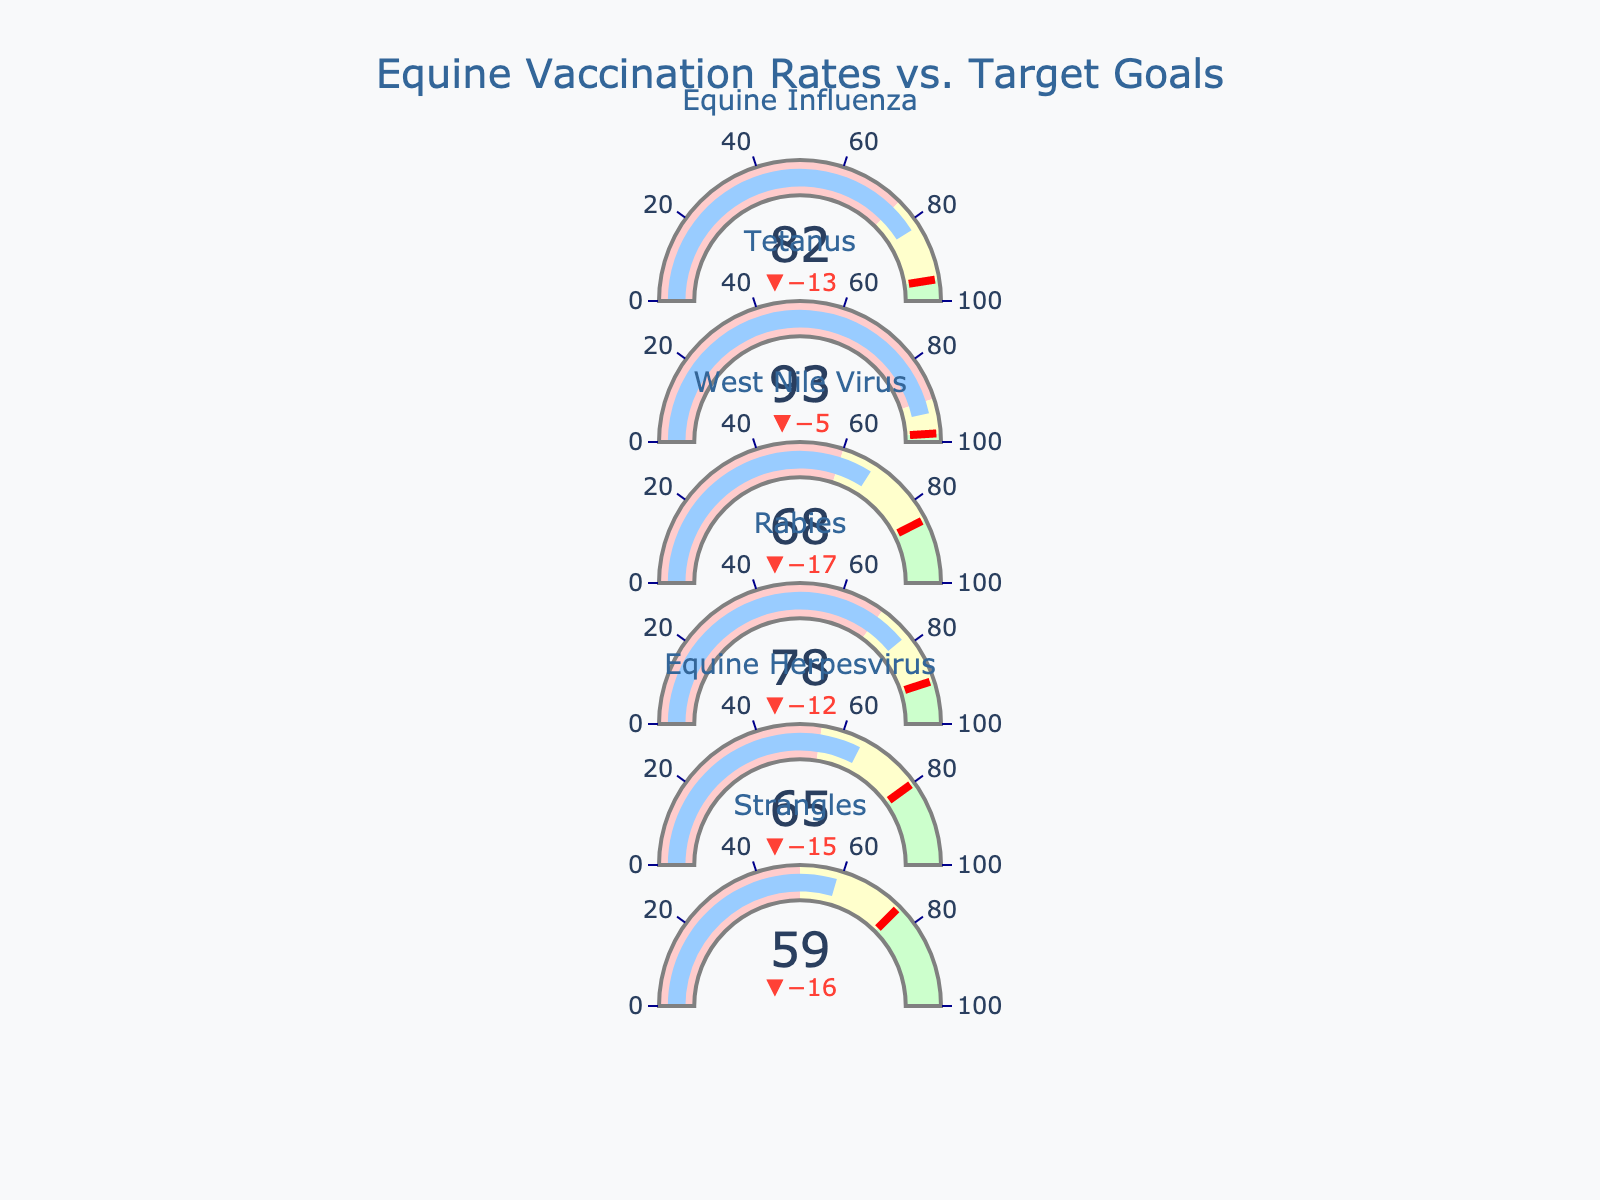What is the actual vaccination rate for Tetanus? Look at the section labeled "Tetanus" in the chart to find the actual vaccination rate.
Answer: 93 What is the discrepancy between the actual and target vaccination rates for West Nile Virus? Find the actual vaccination rate for West Nile Virus (68) and the target rate (85). Subtract the actual rate from the target rate: 85 - 68 = 17
Answer: 17 Among the diseases listed, which one has the lowest vaccination rate? Compare the actual vaccination rates for all diseases: Equine Influenza (82), Tetanus (93), West Nile Virus (68), Rabies (78), Equine Herpesvirus (65), Strangles (59). The lowest rate is for Strangles.
Answer: Strangles How many diseases have an actual vaccination rate above their respective comparison thresholds? Compare actual rates against comparison thresholds: Equine Influenza (82 > 75), Tetanus (93 > 90), West Nile Virus (68 > 60), Rabies (78 > 70), Equine Herpesvirus (65 > 55), Strangles (59 > 50). All six diseases meet this condition.
Answer: 6 Which disease has the smallest difference between the actual and target vaccination rates? Calculate differences: Equine Influenza (95-82=13), Tetanus (98-93=5), West Nile Virus (85-68=17), Rabies (90-78=12), Equine Herpesvirus (80-65=15), Strangles (75-59=16). The smallest difference is for Tetanus.
Answer: Tetanus What's the average actual vaccination rate across all diseases? Add all actual rates: 82 + 93 + 68 + 78 + 65 + 59 = 445. Divide by the number of diseases (6): 445 / 6 ≈ 74.17
Answer: 74.17 What is the target vaccination rate of Rabies and how far is it from the actual rate? Find the target rate for Rabies (90) and the actual rate (78). The distance is 90 - 78 = 12
Answer: 12 Which disease has the target rate closest to 80%? Look at all target rates: Equine Influenza (95), Tetanus (98), West Nile Virus (85), Rabies (90), Equine Herpesvirus (80), Strangles (75). The target rate for Equine Herpesvirus is exactly 80%.
Answer: Equine Herpesvirus Between Equine Influenza and Rabies, which has a higher actual vaccination rate? Compare actual rates: Equine Influenza (82) vs. Rabies (78). Equine Influenza has the higher rate.
Answer: Equine Influenza How many diseases have a target vaccination rate above 90%? Identify target rates above 90: Equine Influenza (95), Tetanus (98), Rabies (90). There are three diseases meeting this condition.
Answer: 3 